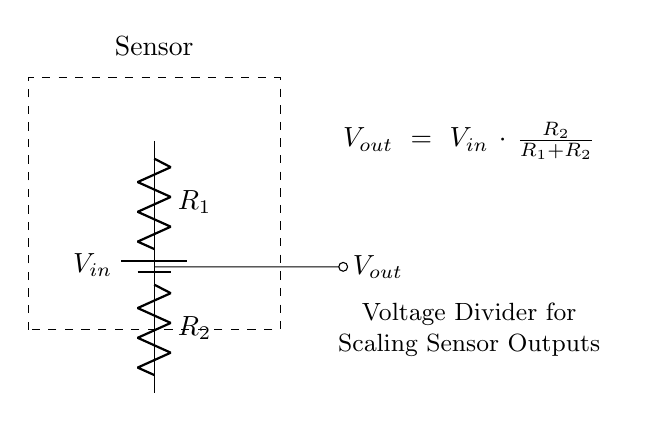What is the input voltage of the circuit? The input voltage is labeled as \( V_{in} \) on the circuit diagram, indicating the voltage provided by the battery.
Answer: \( V_{in} \) What are the resistances in the voltage divider? The resistances are labeled as \( R_1 \) and \( R_2 \) in the circuit diagram, representing the two resistors that form the voltage divider.
Answer: \( R_1, R_2 \) What is the output voltage formula for this circuit? The output voltage is calculated using the formula \( V_{out} = V_{in} \cdot \frac{R_2}{R_1 + R_2} \), which shows the relationship between the output voltage and the resistors.
Answer: \( V_{out} = V_{in} \cdot \frac{R_2}{R_1 + R_2} \) How does increasing \( R_2 \) affect \( V_{out} \)? Increasing \( R_2 \) increases the fraction \( \frac{R_2}{R_1 + R_2} \), which proportionally increases \( V_{out} \) since \( V_{out} \) is directly related to this fraction.
Answer: \( V_{out} \) increases What type of circuit configuration is used for \( V_{out} \) in this example? The output voltage is taken from the junction of the two resistors in a voltage divider configuration, where the resistors are in series.
Answer: Voltage divider What happens to \( V_{out} \) when \( R_1 \) approaches zero? If \( R_1 \) approaches zero, the output voltage \( V_{out} \) will approach \( V_{in} \) because the equation simplifies to \( V_{out} = V_{in} \cdot \frac{R_2}{0 + R_2} \), which equals \( V_{in} \).
Answer: \( V_{in} \) 